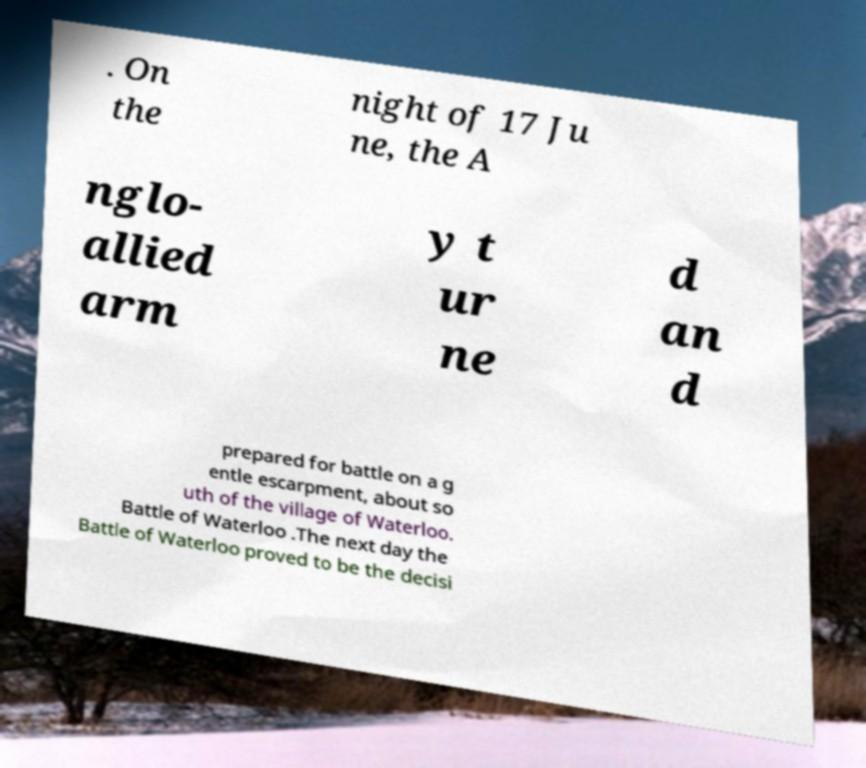For documentation purposes, I need the text within this image transcribed. Could you provide that? . On the night of 17 Ju ne, the A nglo- allied arm y t ur ne d an d prepared for battle on a g entle escarpment, about so uth of the village of Waterloo. Battle of Waterloo .The next day the Battle of Waterloo proved to be the decisi 